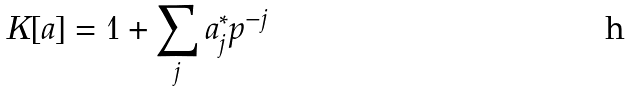Convert formula to latex. <formula><loc_0><loc_0><loc_500><loc_500>K [ a ] = 1 + \sum _ { j } a _ { j } ^ { * } p ^ { - j }</formula> 